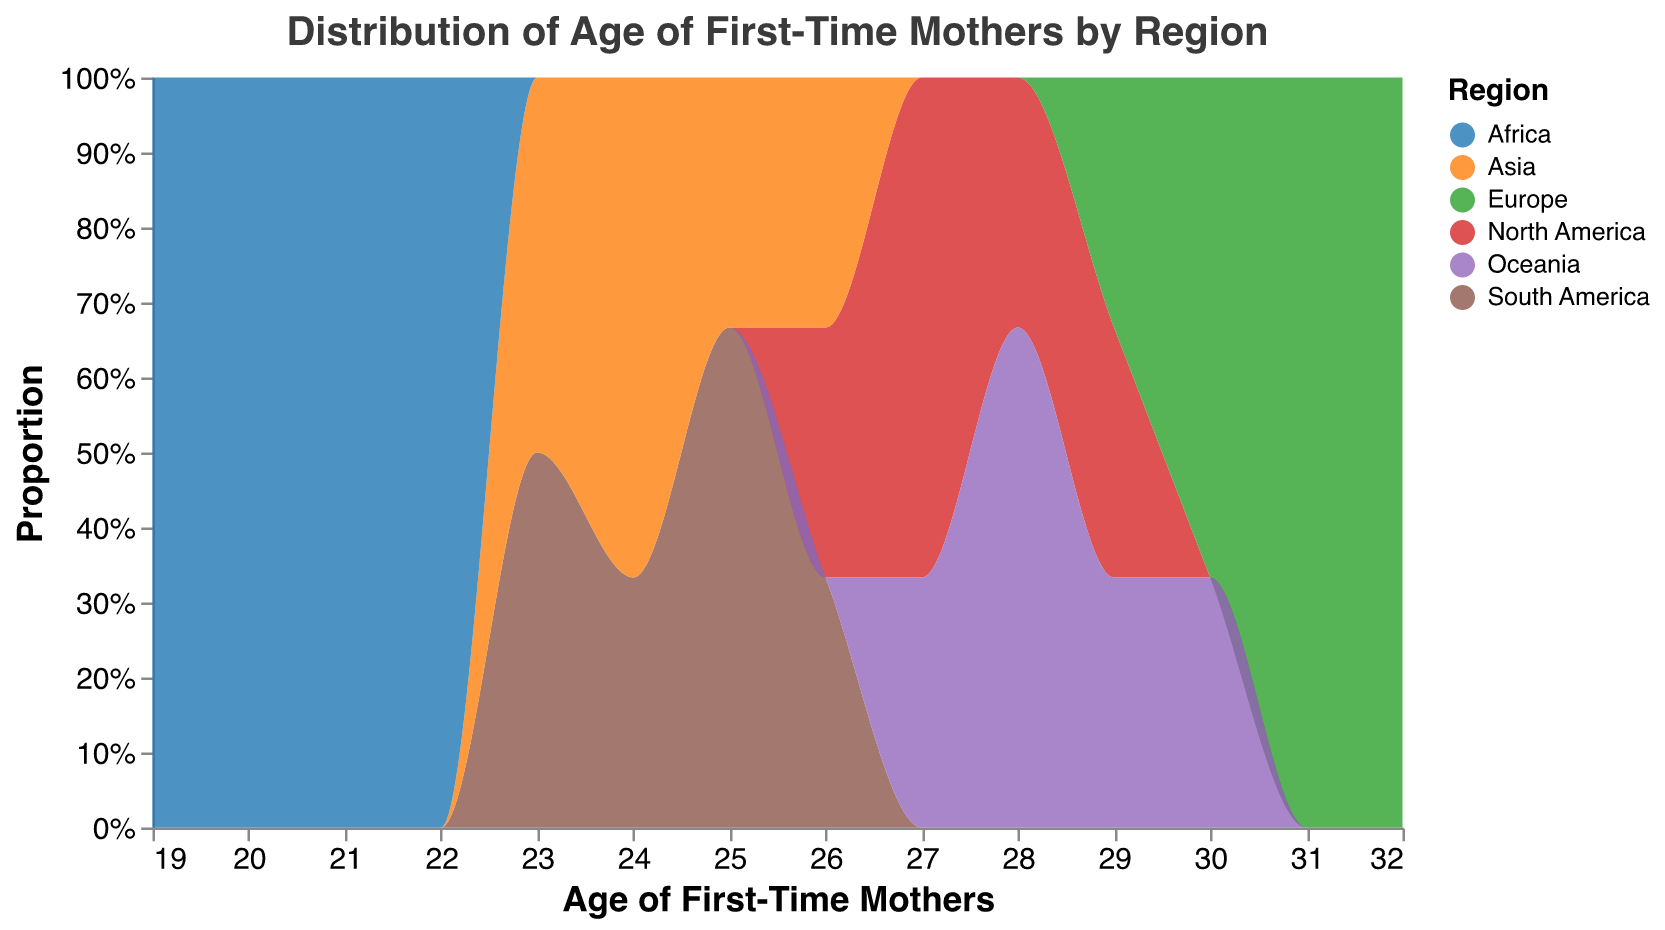What is the title of the figure? The title is typically the first visual clue that sets the context for the rest of the figure. In this case, the title is "Distribution of Age of First-Time Mothers by Region."
Answer: Distribution of Age of First-Time Mothers by Region What is the range of ages for first-time mothers in Africa? The x-axis shows the ages of first-time mothers, and we can identify the range by observing the start and end of the age distribution for Africa on this axis. Ages for Africa range from 19 to 22.
Answer: 19 to 22 Which region has the highest peak in the distribution of first-time mothers aged 30-32? By looking at the y-axis within the age range of 30-32, we can determine which region's distribution has the highest count. The highest peak in this age range is observed for Europe.
Answer: Europe What is the most common age of first-time mothers in South America? To find the most common age, or mode, we can look for the age with the highest peak in the distribution for South America. The highest peak for South America occurs at age 25.
Answer: 25 Which regions have overlapping age distributions for first-time mothers? By observing the color-coded areas and their ranges on the x-axis, we can see where the distributions overlap. Regions that have overlapping age distributions are North America and Oceania, as well as Asia and South America.
Answer: North America and Oceania, Asia and South America How do the ages of first-time mothers in North America compare to those in Africa? By comparing the age ranges on the x-axis and their corresponding heights on the y-axis for North America and Africa, we see that North American mothers tend to have their first child at older ages (26-29) compared to African mothers (19-22).
Answer: North America tends to have older first-time mothers than Africa Calculate the average age of first-time mothers in Oceania. To find the average age, add the ages for Oceania and divide by the number of data points: (27+28+27+28+30) / 5 = 28.
Answer: 28 What proportion of first-time mothers in Asia are aged 24? We need to look at the y-axis for the count values corresponding to the age of 24 in Asia. Two out of five data points for Asia are 24, so the proportion is 2/5 or 40%.
Answer: 40% Can you identify any trends in the age distributions of first-time mothers among the regions? By examining the peak positions and the spread of distributions, we can identify trends such as older ages in Europe and North America, younger ages in Africa and Asia, and some middle ranges in South America and Oceania.
Answer: Older in Europe and North America, younger in Africa and Asia What is the difference in the median age of first-time mothers between Europe and South America? Calculate the median for both regions and then find the difference. For Europe (29, 30, 30, 31, 32), the median is 30. For South America (23, 24, 25, 25, 26), the median is 25. The difference is 30 - 25 = 5.
Answer: 5 